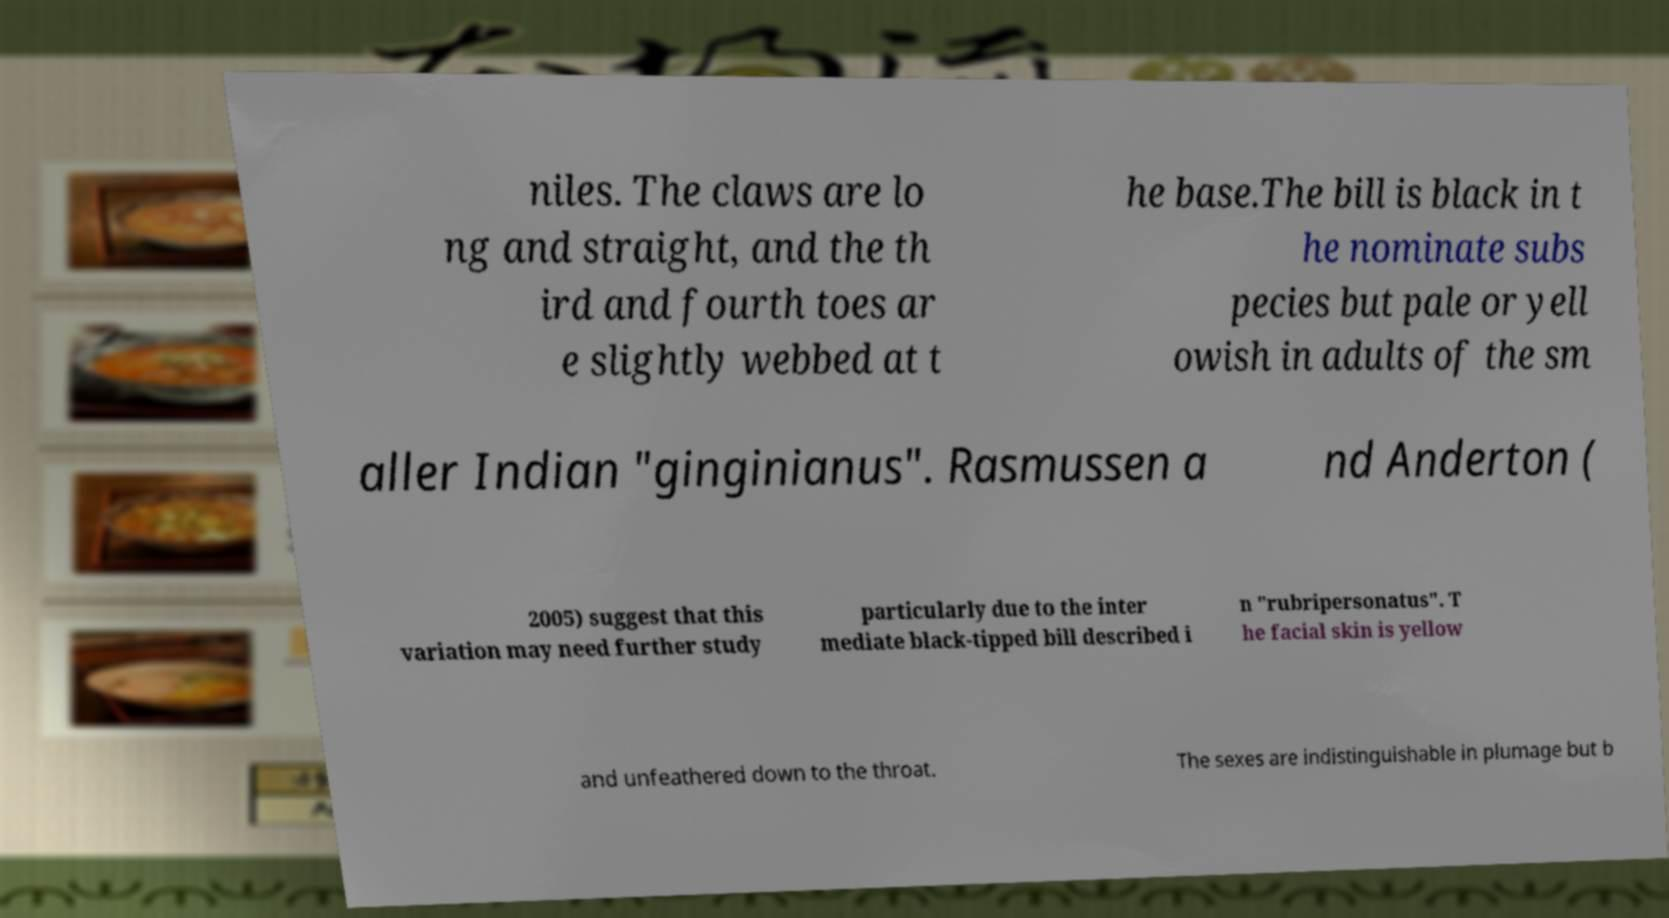Could you extract and type out the text from this image? niles. The claws are lo ng and straight, and the th ird and fourth toes ar e slightly webbed at t he base.The bill is black in t he nominate subs pecies but pale or yell owish in adults of the sm aller Indian "ginginianus". Rasmussen a nd Anderton ( 2005) suggest that this variation may need further study particularly due to the inter mediate black-tipped bill described i n "rubripersonatus". T he facial skin is yellow and unfeathered down to the throat. The sexes are indistinguishable in plumage but b 